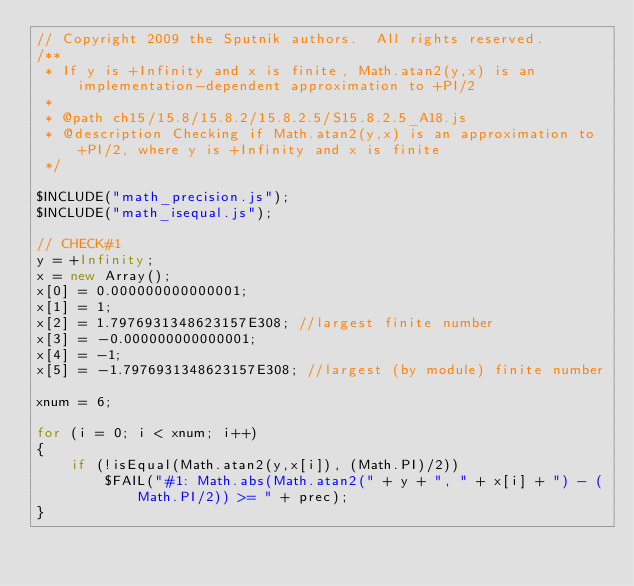Convert code to text. <code><loc_0><loc_0><loc_500><loc_500><_JavaScript_>// Copyright 2009 the Sputnik authors.  All rights reserved.
/**
 * If y is +Infinity and x is finite, Math.atan2(y,x) is an implementation-dependent approximation to +PI/2
 *
 * @path ch15/15.8/15.8.2/15.8.2.5/S15.8.2.5_A18.js
 * @description Checking if Math.atan2(y,x) is an approximation to +PI/2, where y is +Infinity and x is finite
 */

$INCLUDE("math_precision.js");
$INCLUDE("math_isequal.js"); 
 
// CHECK#1
y = +Infinity;
x = new Array();
x[0] = 0.000000000000001;
x[1] = 1;
x[2] = 1.7976931348623157E308; //largest finite number
x[3] = -0.000000000000001;
x[4] = -1;
x[5] = -1.7976931348623157E308; //largest (by module) finite number 
 
xnum = 6;

for (i = 0; i < xnum; i++)
{
	if (!isEqual(Math.atan2(y,x[i]), (Math.PI)/2))
		$FAIL("#1: Math.abs(Math.atan2(" + y + ", " + x[i] + ") - (Math.PI/2)) >= " + prec);
}

</code> 